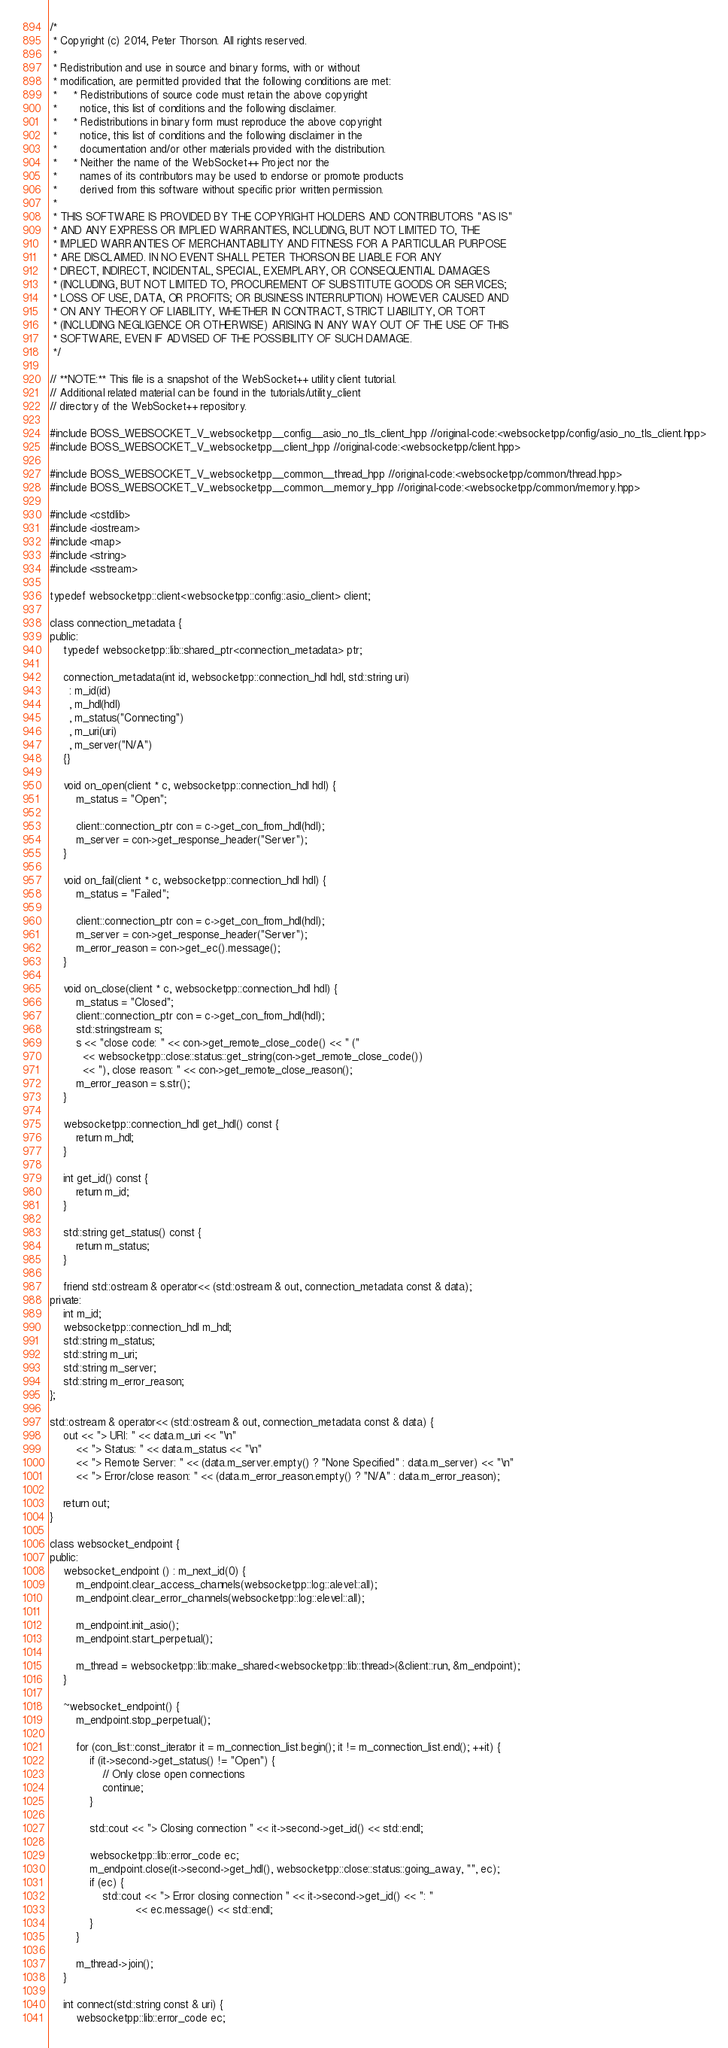<code> <loc_0><loc_0><loc_500><loc_500><_C++_>/*
 * Copyright (c) 2014, Peter Thorson. All rights reserved.
 *
 * Redistribution and use in source and binary forms, with or without
 * modification, are permitted provided that the following conditions are met:
 *     * Redistributions of source code must retain the above copyright
 *       notice, this list of conditions and the following disclaimer.
 *     * Redistributions in binary form must reproduce the above copyright
 *       notice, this list of conditions and the following disclaimer in the
 *       documentation and/or other materials provided with the distribution.
 *     * Neither the name of the WebSocket++ Project nor the
 *       names of its contributors may be used to endorse or promote products
 *       derived from this software without specific prior written permission.
 *
 * THIS SOFTWARE IS PROVIDED BY THE COPYRIGHT HOLDERS AND CONTRIBUTORS "AS IS"
 * AND ANY EXPRESS OR IMPLIED WARRANTIES, INCLUDING, BUT NOT LIMITED TO, THE
 * IMPLIED WARRANTIES OF MERCHANTABILITY AND FITNESS FOR A PARTICULAR PURPOSE
 * ARE DISCLAIMED. IN NO EVENT SHALL PETER THORSON BE LIABLE FOR ANY
 * DIRECT, INDIRECT, INCIDENTAL, SPECIAL, EXEMPLARY, OR CONSEQUENTIAL DAMAGES
 * (INCLUDING, BUT NOT LIMITED TO, PROCUREMENT OF SUBSTITUTE GOODS OR SERVICES;
 * LOSS OF USE, DATA, OR PROFITS; OR BUSINESS INTERRUPTION) HOWEVER CAUSED AND
 * ON ANY THEORY OF LIABILITY, WHETHER IN CONTRACT, STRICT LIABILITY, OR TORT
 * (INCLUDING NEGLIGENCE OR OTHERWISE) ARISING IN ANY WAY OUT OF THE USE OF THIS
 * SOFTWARE, EVEN IF ADVISED OF THE POSSIBILITY OF SUCH DAMAGE.
 */

// **NOTE:** This file is a snapshot of the WebSocket++ utility client tutorial.
// Additional related material can be found in the tutorials/utility_client
// directory of the WebSocket++ repository.

#include BOSS_WEBSOCKET_V_websocketpp__config__asio_no_tls_client_hpp //original-code:<websocketpp/config/asio_no_tls_client.hpp>
#include BOSS_WEBSOCKET_V_websocketpp__client_hpp //original-code:<websocketpp/client.hpp>

#include BOSS_WEBSOCKET_V_websocketpp__common__thread_hpp //original-code:<websocketpp/common/thread.hpp>
#include BOSS_WEBSOCKET_V_websocketpp__common__memory_hpp //original-code:<websocketpp/common/memory.hpp>

#include <cstdlib>
#include <iostream>
#include <map>
#include <string>
#include <sstream>

typedef websocketpp::client<websocketpp::config::asio_client> client;

class connection_metadata {
public:
    typedef websocketpp::lib::shared_ptr<connection_metadata> ptr;

    connection_metadata(int id, websocketpp::connection_hdl hdl, std::string uri)
      : m_id(id)
      , m_hdl(hdl)
      , m_status("Connecting")
      , m_uri(uri)
      , m_server("N/A")
    {}

    void on_open(client * c, websocketpp::connection_hdl hdl) {
        m_status = "Open";

        client::connection_ptr con = c->get_con_from_hdl(hdl);
        m_server = con->get_response_header("Server");
    }

    void on_fail(client * c, websocketpp::connection_hdl hdl) {
        m_status = "Failed";

        client::connection_ptr con = c->get_con_from_hdl(hdl);
        m_server = con->get_response_header("Server");
        m_error_reason = con->get_ec().message();
    }
    
    void on_close(client * c, websocketpp::connection_hdl hdl) {
        m_status = "Closed";
        client::connection_ptr con = c->get_con_from_hdl(hdl);
        std::stringstream s;
        s << "close code: " << con->get_remote_close_code() << " (" 
          << websocketpp::close::status::get_string(con->get_remote_close_code()) 
          << "), close reason: " << con->get_remote_close_reason();
        m_error_reason = s.str();
    }

    websocketpp::connection_hdl get_hdl() const {
        return m_hdl;
    }
    
    int get_id() const {
        return m_id;
    }
    
    std::string get_status() const {
        return m_status;
    }

    friend std::ostream & operator<< (std::ostream & out, connection_metadata const & data);
private:
    int m_id;
    websocketpp::connection_hdl m_hdl;
    std::string m_status;
    std::string m_uri;
    std::string m_server;
    std::string m_error_reason;
};

std::ostream & operator<< (std::ostream & out, connection_metadata const & data) {
    out << "> URI: " << data.m_uri << "\n"
        << "> Status: " << data.m_status << "\n"
        << "> Remote Server: " << (data.m_server.empty() ? "None Specified" : data.m_server) << "\n"
        << "> Error/close reason: " << (data.m_error_reason.empty() ? "N/A" : data.m_error_reason);

    return out;
}

class websocket_endpoint {
public:
    websocket_endpoint () : m_next_id(0) {
        m_endpoint.clear_access_channels(websocketpp::log::alevel::all);
        m_endpoint.clear_error_channels(websocketpp::log::elevel::all);

        m_endpoint.init_asio();
        m_endpoint.start_perpetual();

        m_thread = websocketpp::lib::make_shared<websocketpp::lib::thread>(&client::run, &m_endpoint);
    }

    ~websocket_endpoint() {
        m_endpoint.stop_perpetual();
        
        for (con_list::const_iterator it = m_connection_list.begin(); it != m_connection_list.end(); ++it) {
            if (it->second->get_status() != "Open") {
                // Only close open connections
                continue;
            }
            
            std::cout << "> Closing connection " << it->second->get_id() << std::endl;
            
            websocketpp::lib::error_code ec;
            m_endpoint.close(it->second->get_hdl(), websocketpp::close::status::going_away, "", ec);
            if (ec) {
                std::cout << "> Error closing connection " << it->second->get_id() << ": "  
                          << ec.message() << std::endl;
            }
        }
        
        m_thread->join();
    }

    int connect(std::string const & uri) {
        websocketpp::lib::error_code ec;
</code> 